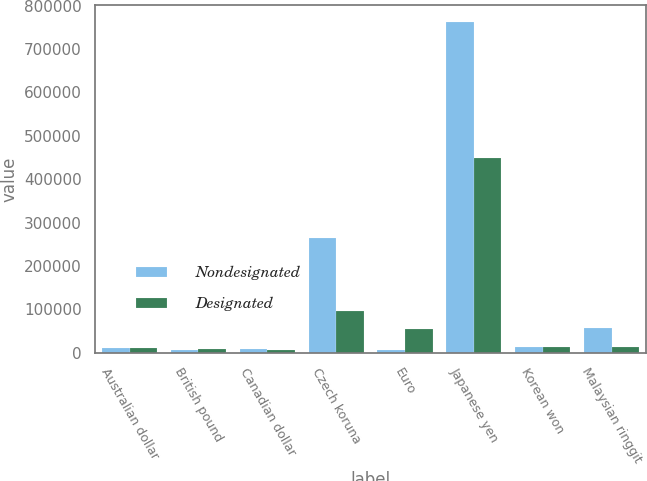<chart> <loc_0><loc_0><loc_500><loc_500><stacked_bar_chart><ecel><fcel>Australian dollar<fcel>British pound<fcel>Canadian dollar<fcel>Czech koruna<fcel>Euro<fcel>Japanese yen<fcel>Korean won<fcel>Malaysian ringgit<nl><fcel>Nondesignated<fcel>11240<fcel>5700<fcel>9726<fcel>265226<fcel>6537<fcel>762550<fcel>12684<fcel>55890<nl><fcel>Designated<fcel>11641<fcel>8933<fcel>7231<fcel>95473<fcel>55185<fcel>447600<fcel>12684<fcel>13727<nl></chart> 